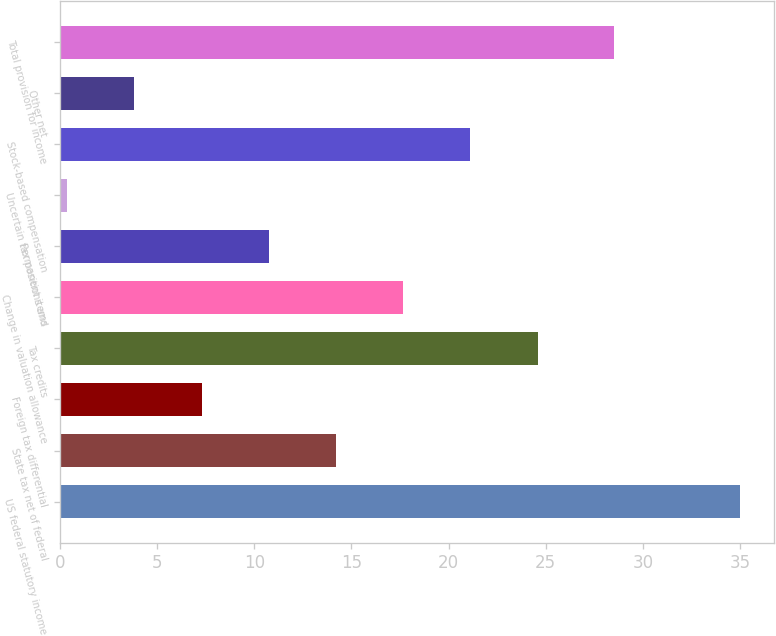Convert chart to OTSL. <chart><loc_0><loc_0><loc_500><loc_500><bar_chart><fcel>US federal statutory income<fcel>State tax net of federal<fcel>Foreign tax differential<fcel>Tax credits<fcel>Change in valuation allowance<fcel>Permanent items<fcel>Uncertain tax positions and<fcel>Stock-based compensation<fcel>Other net<fcel>Total provision for income<nl><fcel>35<fcel>14.21<fcel>7.29<fcel>24.59<fcel>17.67<fcel>10.75<fcel>0.37<fcel>21.13<fcel>3.83<fcel>28.52<nl></chart> 